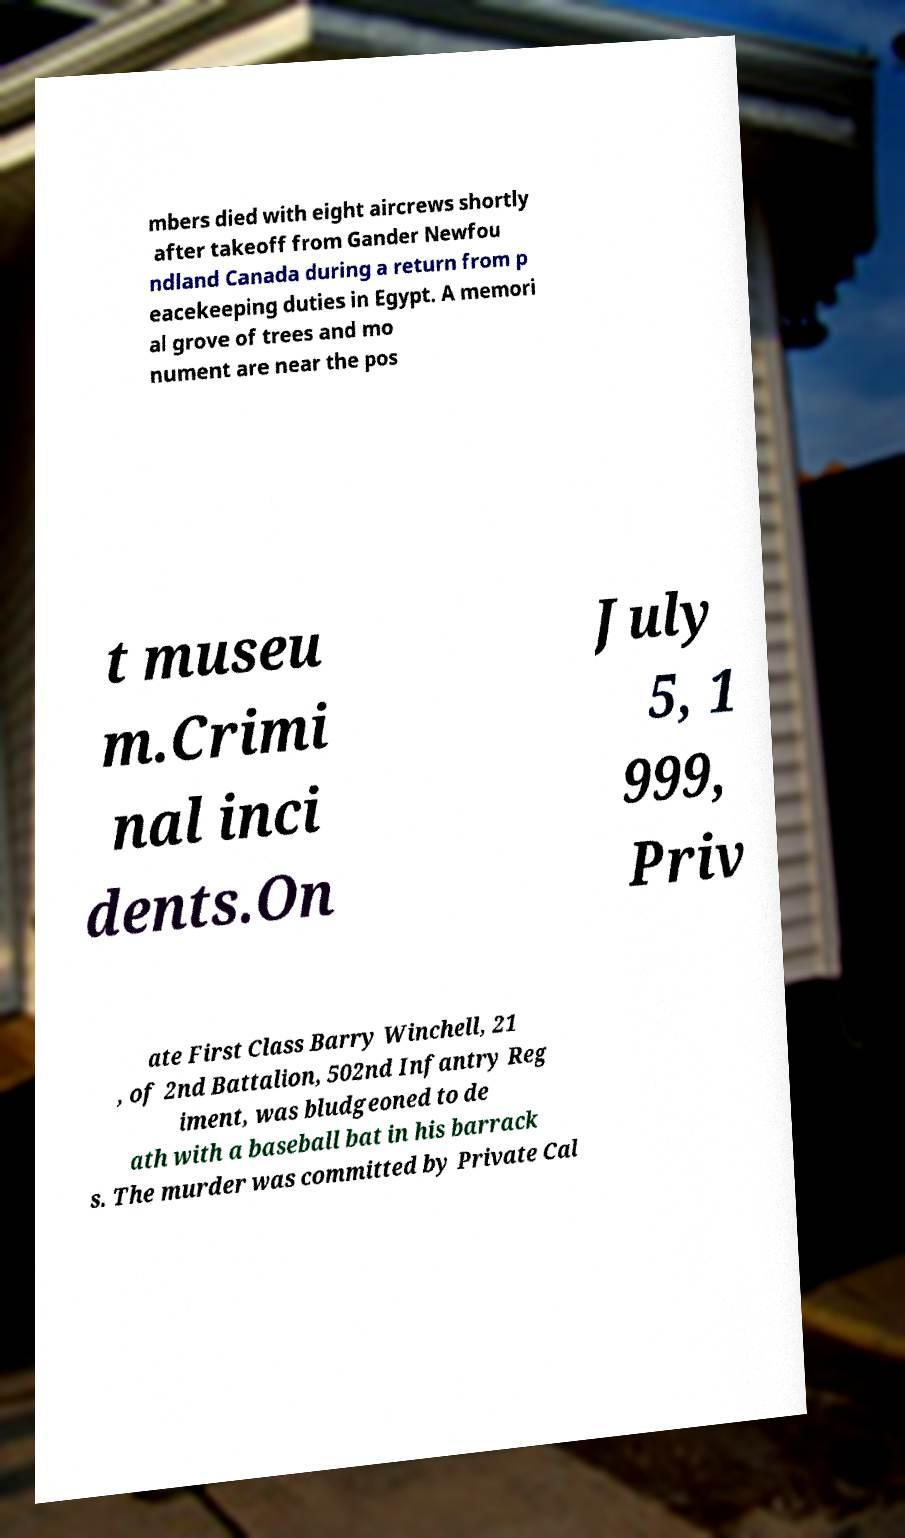There's text embedded in this image that I need extracted. Can you transcribe it verbatim? mbers died with eight aircrews shortly after takeoff from Gander Newfou ndland Canada during a return from p eacekeeping duties in Egypt. A memori al grove of trees and mo nument are near the pos t museu m.Crimi nal inci dents.On July 5, 1 999, Priv ate First Class Barry Winchell, 21 , of 2nd Battalion, 502nd Infantry Reg iment, was bludgeoned to de ath with a baseball bat in his barrack s. The murder was committed by Private Cal 